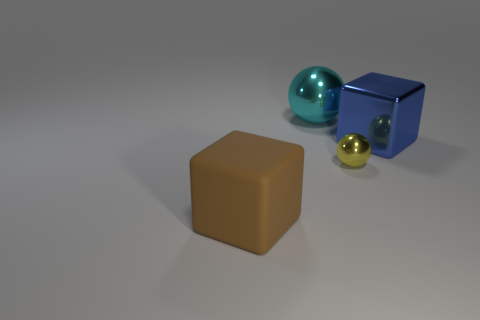What is the material of the cube that is left of the big cyan ball?
Keep it short and to the point. Rubber. Are there fewer rubber cubes that are in front of the blue block than brown matte cylinders?
Give a very brief answer. No. There is a big metallic object behind the blue metal object that is right of the large ball; what shape is it?
Give a very brief answer. Sphere. What is the color of the big metallic cube?
Your response must be concise. Blue. What number of other objects are the same size as the cyan shiny sphere?
Ensure brevity in your answer.  2. What is the material of the large thing that is on the left side of the small yellow shiny thing and in front of the big cyan metal thing?
Provide a short and direct response. Rubber. There is a thing in front of the yellow metal sphere; is it the same size as the yellow metallic ball?
Keep it short and to the point. No. What number of things are both in front of the large cyan metallic object and on the right side of the large matte block?
Your response must be concise. 2. There is a shiny sphere to the right of the object behind the large blue metallic block; what number of metallic cubes are right of it?
Your answer should be compact. 1. The large rubber thing is what shape?
Your answer should be very brief. Cube. 